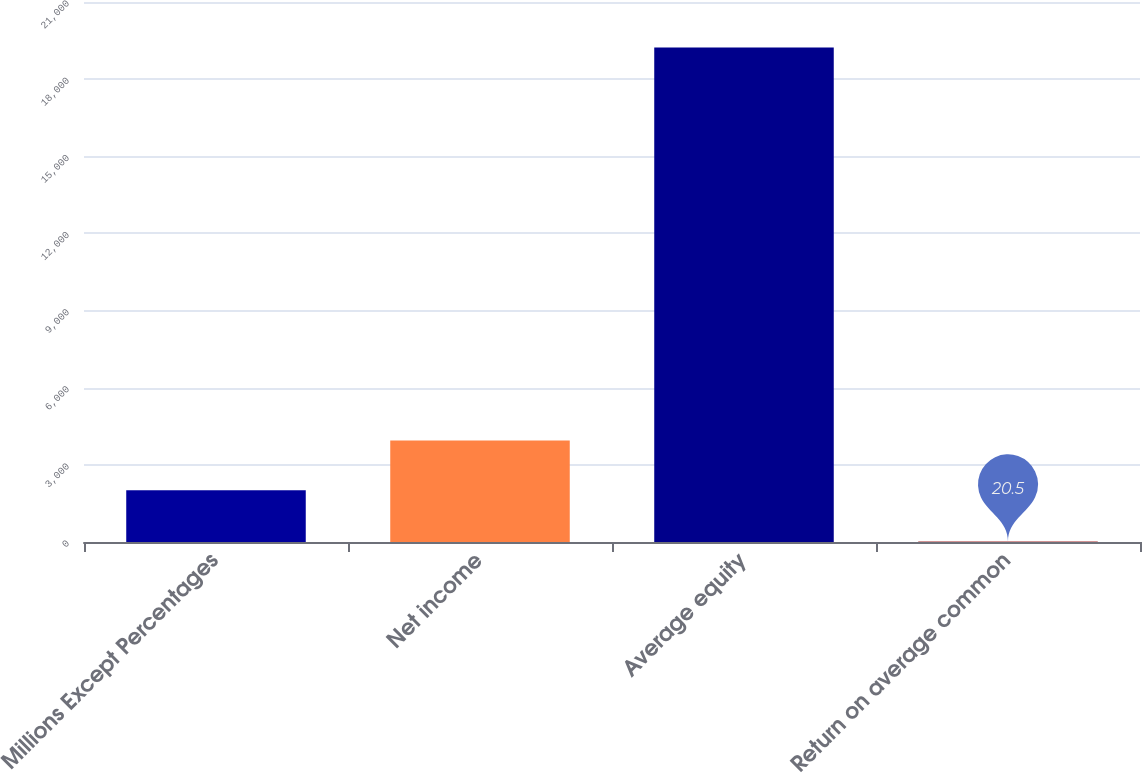Convert chart. <chart><loc_0><loc_0><loc_500><loc_500><bar_chart><fcel>Millions Except Percentages<fcel>Net income<fcel>Average equity<fcel>Return on average common<nl><fcel>2012<fcel>3943<fcel>19228<fcel>20.5<nl></chart> 